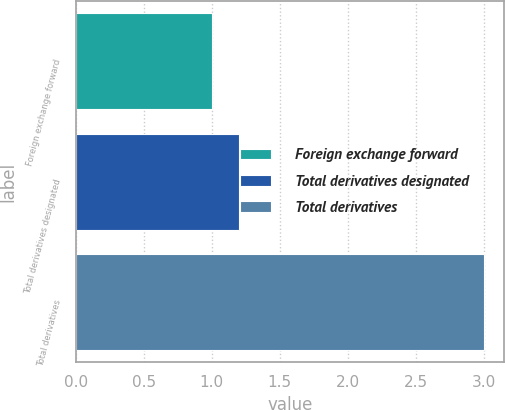<chart> <loc_0><loc_0><loc_500><loc_500><bar_chart><fcel>Foreign exchange forward<fcel>Total derivatives designated<fcel>Total derivatives<nl><fcel>1<fcel>1.2<fcel>3<nl></chart> 